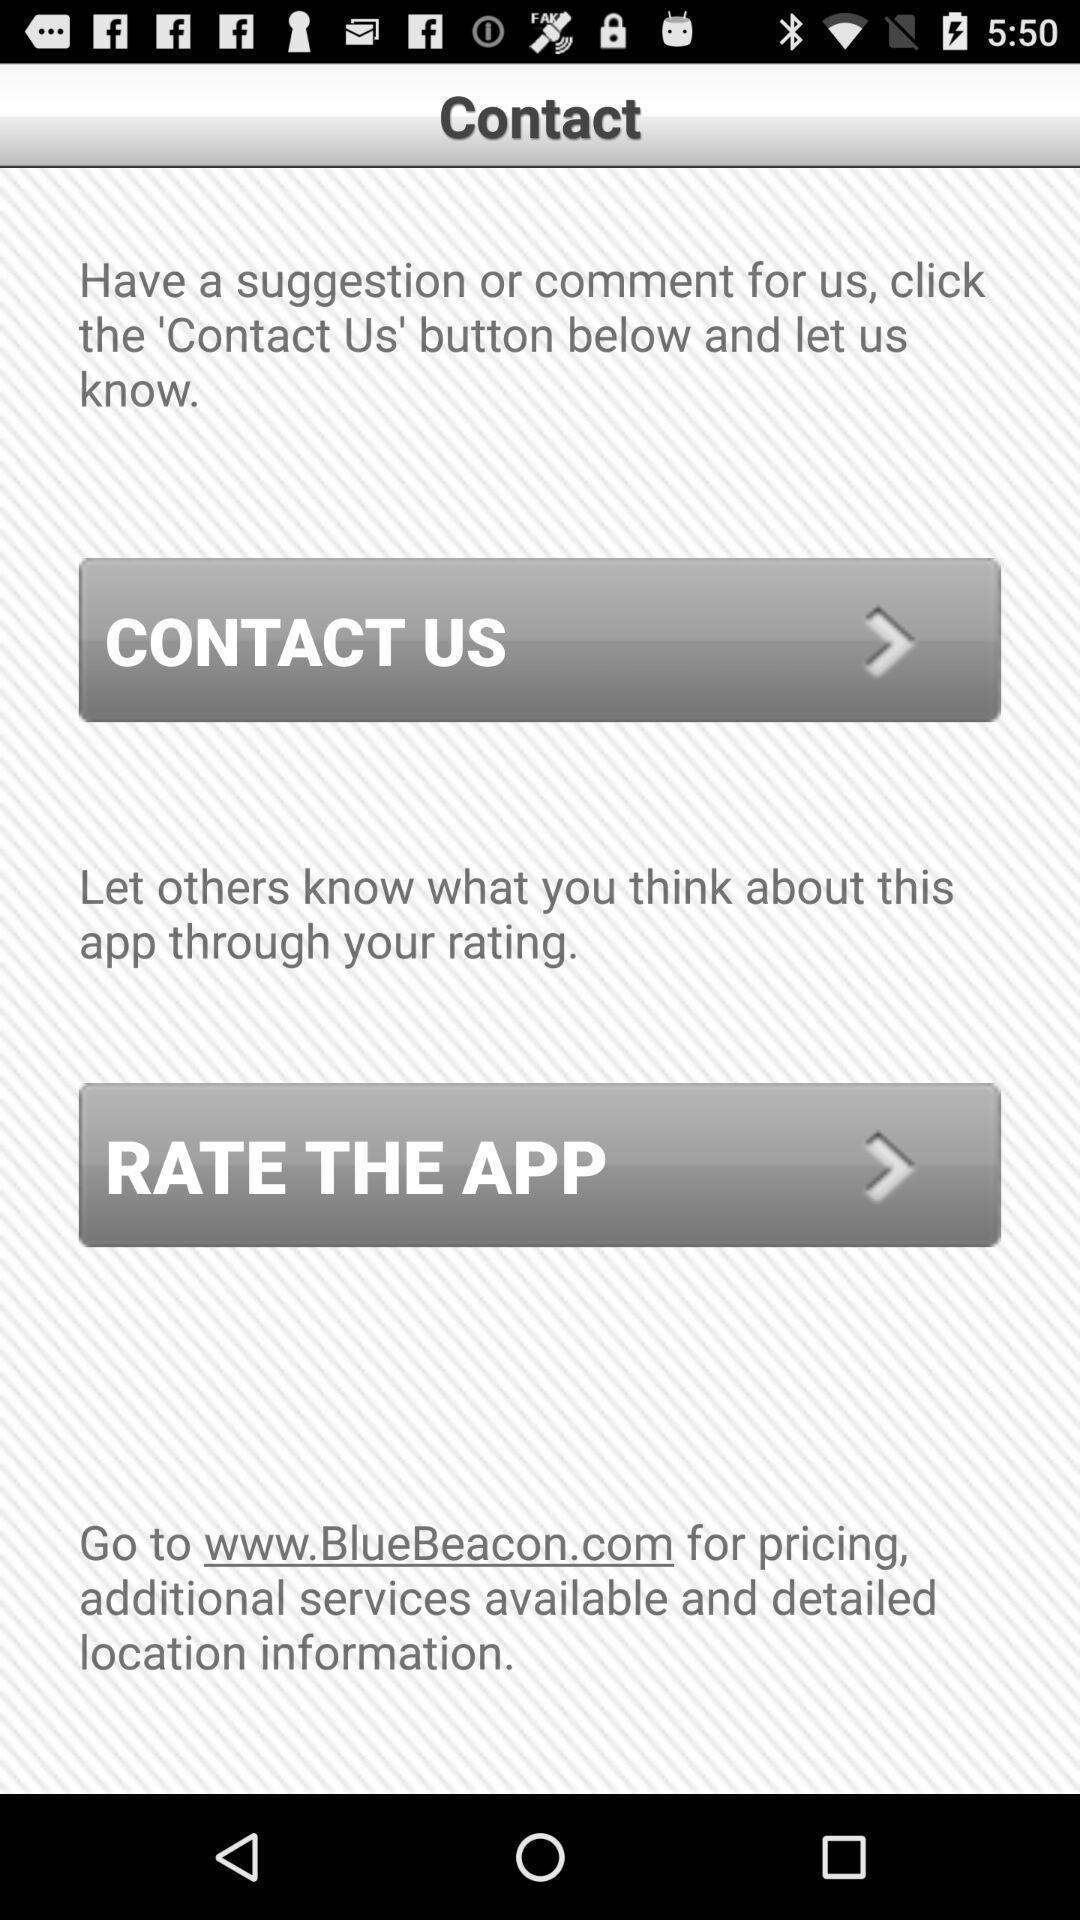Summarize the information in this screenshot. Page shows to rate the app experience. 